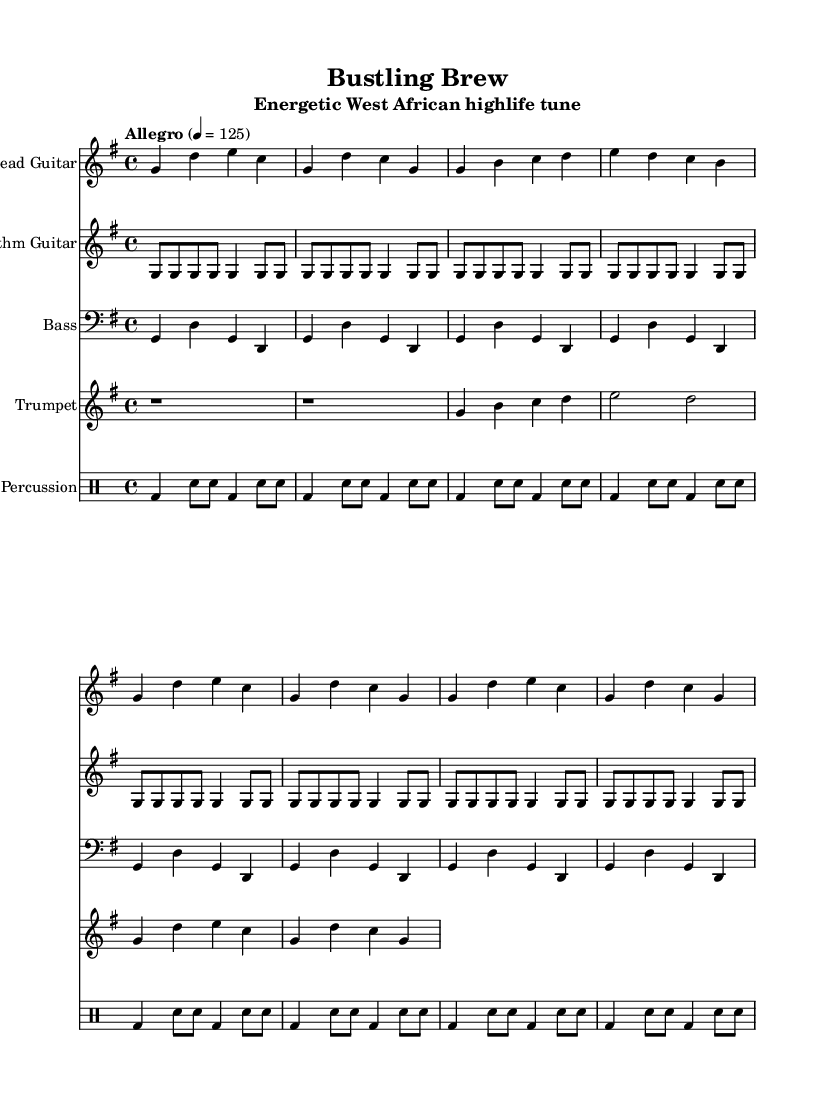What is the key signature of this music? The key signature is G major, which has one sharp (F#). This can be identified by looking at the key signature indicated at the beginning of the piece.
Answer: G major What is the time signature of the piece? The time signature is 4/4, which is represented at the beginning of the sheet music. This means there are four beats in each measure and a quarter note receives one beat.
Answer: 4/4 What is the tempo marking for this piece? The tempo marking is "Allegro" with a metronome marking of 125 beats per minute. This is indicated in the tempo section at the beginning and defines the speed of the piece.
Answer: Allegro, 125 What instrument plays the main melody in this arrangement? The lead guitar plays the main melody, which is presented in a separate staff labeled "Lead Guitar." This indicates that it carries the primary melodic line throughout the piece.
Answer: Lead Guitar How many measures are in the introductory part? The intro consists of two measures as indicated by the grouping of the notes at the beginning of the lead guitar part. Each grouping of notes corresponds to one measure.
Answer: 2 Which section of the music repeats two times, according to the structure? The chorus is the section that repeats two times, as can be inferred from the repeated lines of music for the lead guitar. Each repetition denotes that the same melody is played in succession.
Answer: Chorus What rhythmic pattern is predominantly used in the percussion section? The rhythm pattern in the percussion section primarily consists of bass drum and snare hits in a repeating pattern, which brings energy to the piece typical of highlife music. This can be discerned from how the percussion notes are organized.
Answer: Bass and snare 